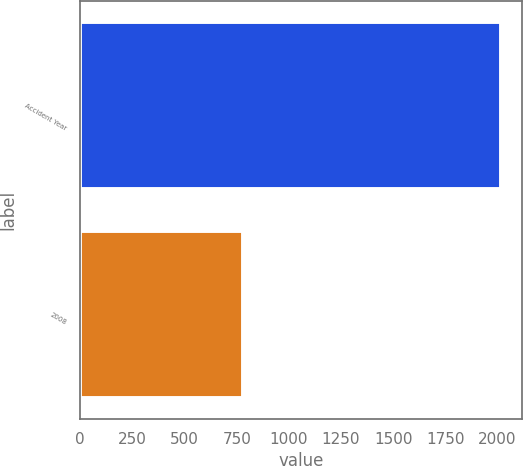<chart> <loc_0><loc_0><loc_500><loc_500><bar_chart><fcel>Accident Year<fcel>2008<nl><fcel>2016<fcel>778<nl></chart> 